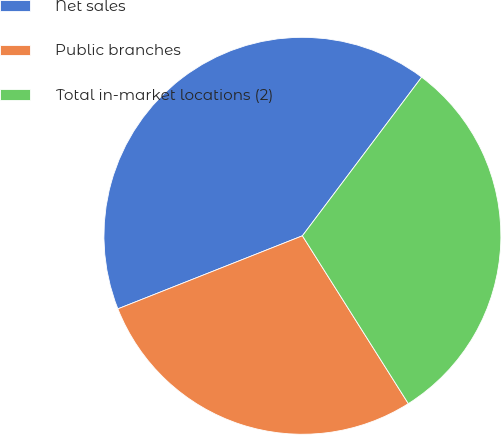Convert chart. <chart><loc_0><loc_0><loc_500><loc_500><pie_chart><fcel>Net sales<fcel>Public branches<fcel>Total in-market locations (2)<nl><fcel>41.26%<fcel>27.96%<fcel>30.78%<nl></chart> 